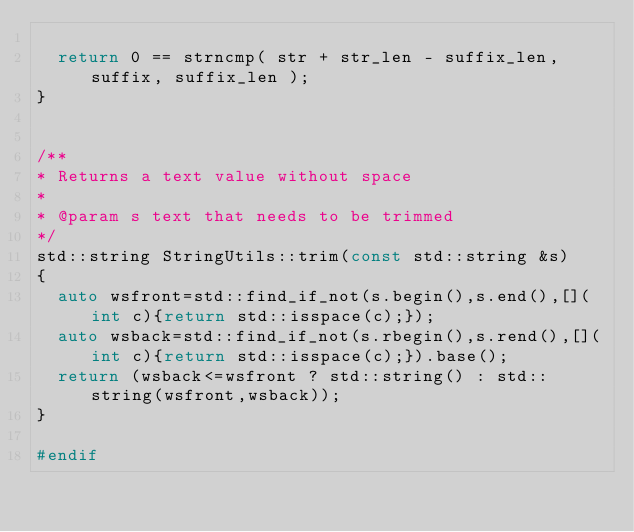<code> <loc_0><loc_0><loc_500><loc_500><_C++_>
  return 0 == strncmp( str + str_len - suffix_len, suffix, suffix_len );
}


/**
* Returns a text value without space
*
* @param s text that needs to be trimmed
*/
std::string StringUtils::trim(const std::string &s)
{
  auto wsfront=std::find_if_not(s.begin(),s.end(),[](int c){return std::isspace(c);});
  auto wsback=std::find_if_not(s.rbegin(),s.rend(),[](int c){return std::isspace(c);}).base();
  return (wsback<=wsfront ? std::string() : std::string(wsfront,wsback));
}

#endif</code> 